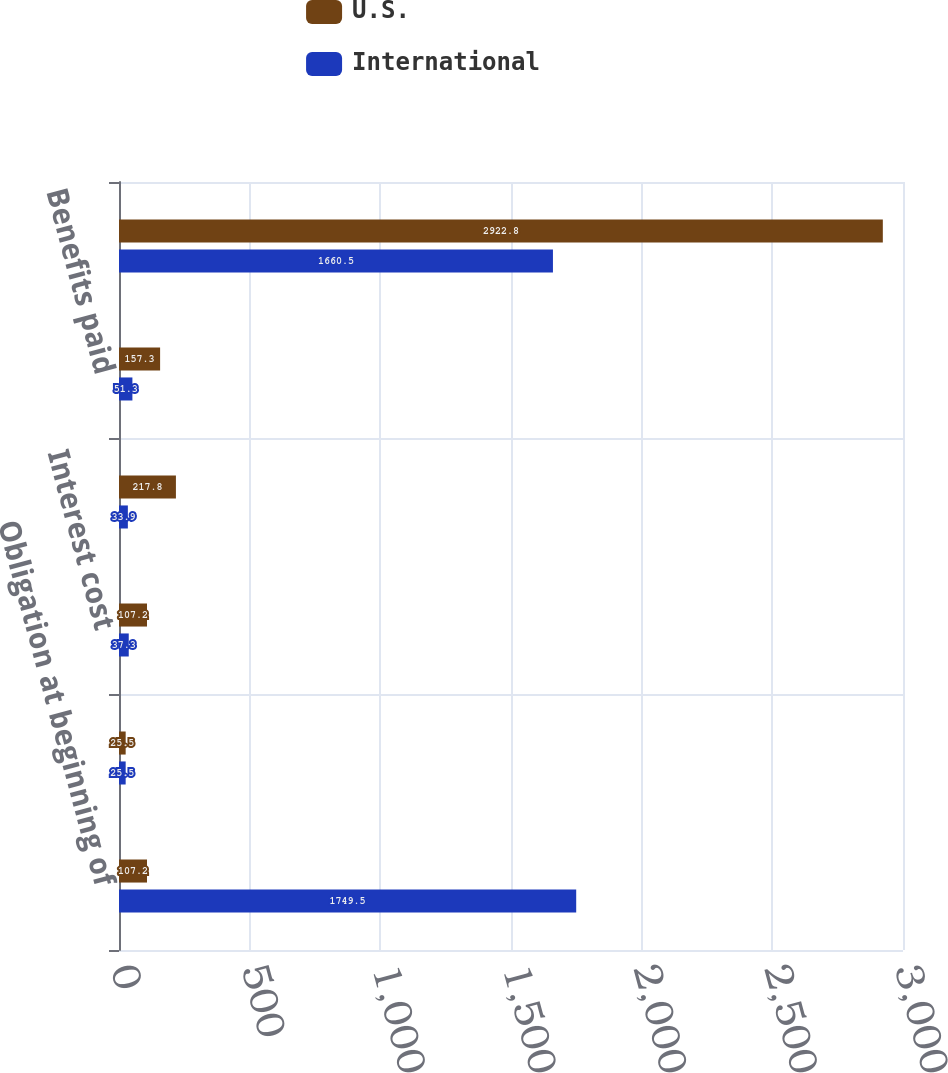Convert chart. <chart><loc_0><loc_0><loc_500><loc_500><stacked_bar_chart><ecel><fcel>Obligation at beginning of<fcel>Service cost<fcel>Interest cost<fcel>Actuarial gain<fcel>Benefits paid<fcel>Obligation at End of Year<nl><fcel>U.S.<fcel>107.2<fcel>25.5<fcel>107.2<fcel>217.8<fcel>157.3<fcel>2922.8<nl><fcel>International<fcel>1749.5<fcel>25.5<fcel>37.3<fcel>33.9<fcel>51.3<fcel>1660.5<nl></chart> 